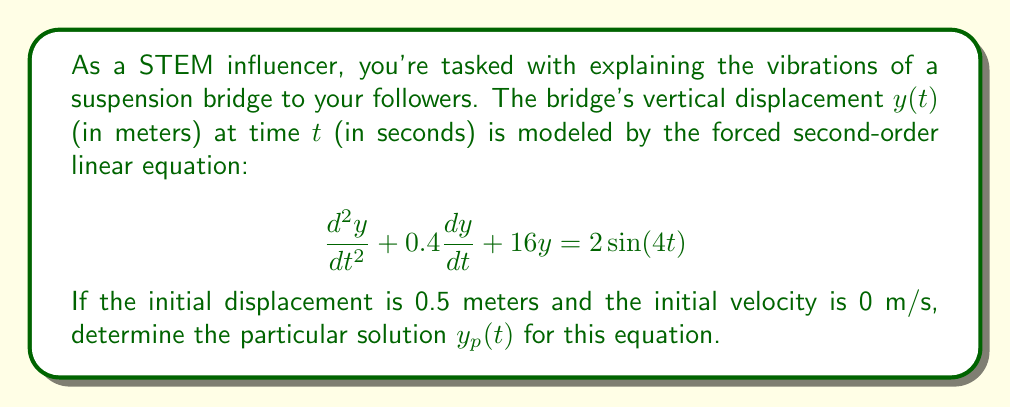Solve this math problem. To solve this problem, we'll follow these steps:

1) The general form of a forced second-order linear equation is:
   $$\frac{d^2y}{dt^2} + 2\zeta\omega_n\frac{dy}{dt} + \omega_n^2y = F(t)$$

2) Comparing our equation to the general form, we can identify:
   $2\zeta\omega_n = 0.4$
   $\omega_n^2 = 16$
   $F(t) = 2\sin(4t)$

3) For the particular solution, we assume a form:
   $$y_p(t) = A\sin(4t) + B\cos(4t)$$

4) We need to find A and B. Substituting $y_p(t)$ into the original equation:

   $$(-16A+1.6B+16A)\sin(4t) + (-16B-1.6A+16B)\cos(4t) = 2\sin(4t)$$

5) Equating coefficients:
   $1.6B = 2$
   $-1.6A = 0$

6) Solving these equations:
   $B = 1.25$
   $A = 0$

Therefore, the particular solution is:
$$y_p(t) = 1.25\cos(4t)$$
Answer: $y_p(t) = 1.25\cos(4t)$ 